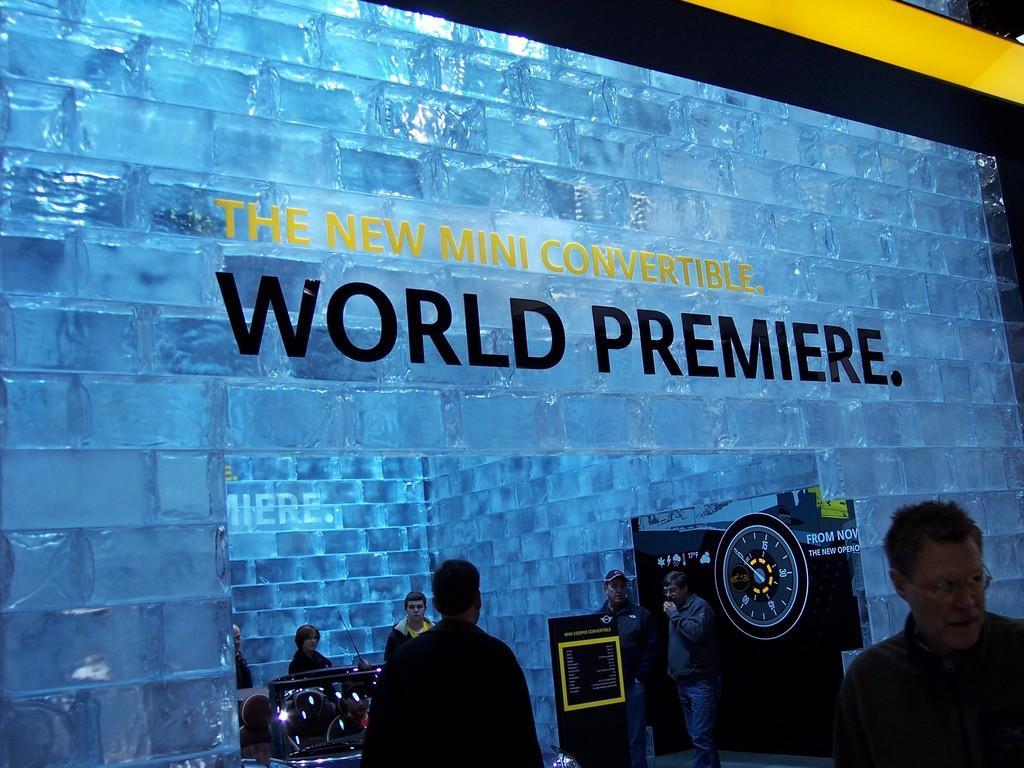In one or two sentences, can you explain what this image depicts? In the image there are few persons standing in the front and behind it seems to be store made of ice cubes with some equipment inside it. 